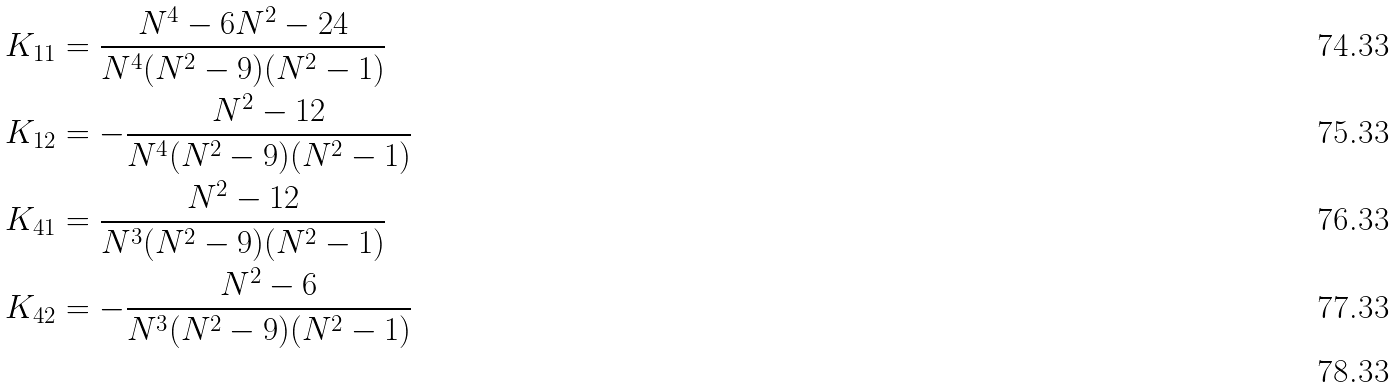<formula> <loc_0><loc_0><loc_500><loc_500>K _ { 1 1 } & = \frac { N ^ { 4 } - 6 N ^ { 2 } - 2 4 } { N ^ { 4 } ( N ^ { 2 } - 9 ) ( N ^ { 2 } - 1 ) } \\ K _ { 1 2 } & = - \frac { N ^ { 2 } - 1 2 } { N ^ { 4 } ( N ^ { 2 } - 9 ) ( N ^ { 2 } - 1 ) } \\ K _ { 4 1 } & = \frac { N ^ { 2 } - 1 2 } { N ^ { 3 } ( N ^ { 2 } - 9 ) ( N ^ { 2 } - 1 ) } \\ K _ { 4 2 } & = - \frac { N ^ { 2 } - 6 } { N ^ { 3 } ( N ^ { 2 } - 9 ) ( N ^ { 2 } - 1 ) } \\</formula> 